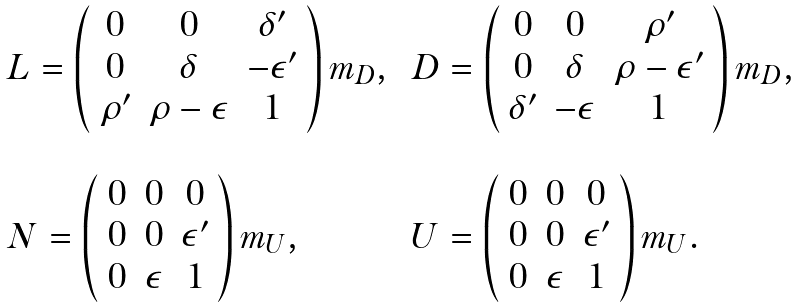Convert formula to latex. <formula><loc_0><loc_0><loc_500><loc_500>\begin{array} { l l } L = \left ( \begin{array} { c c c } 0 & 0 & \delta ^ { \prime } \\ 0 & \delta & - \epsilon ^ { \prime } \\ \rho ^ { \prime } & \rho - \epsilon & 1 \end{array} \right ) m _ { D } , \, & D = \left ( \begin{array} { c c c } 0 & 0 & \rho ^ { \prime } \\ 0 & \delta & \rho - \epsilon ^ { \prime } \\ \delta ^ { \prime } & - \epsilon & 1 \end{array} \right ) m _ { D } , \\ \\ N = \left ( \begin{array} { c c c } 0 & 0 & 0 \\ 0 & 0 & \epsilon ^ { \prime } \\ 0 & \epsilon & 1 \end{array} \right ) m _ { U } , \, & U = \left ( \begin{array} { c c c } 0 & 0 & 0 \\ 0 & 0 & \epsilon ^ { \prime } \\ 0 & \epsilon & 1 \end{array} \right ) m _ { U } . \end{array}</formula> 